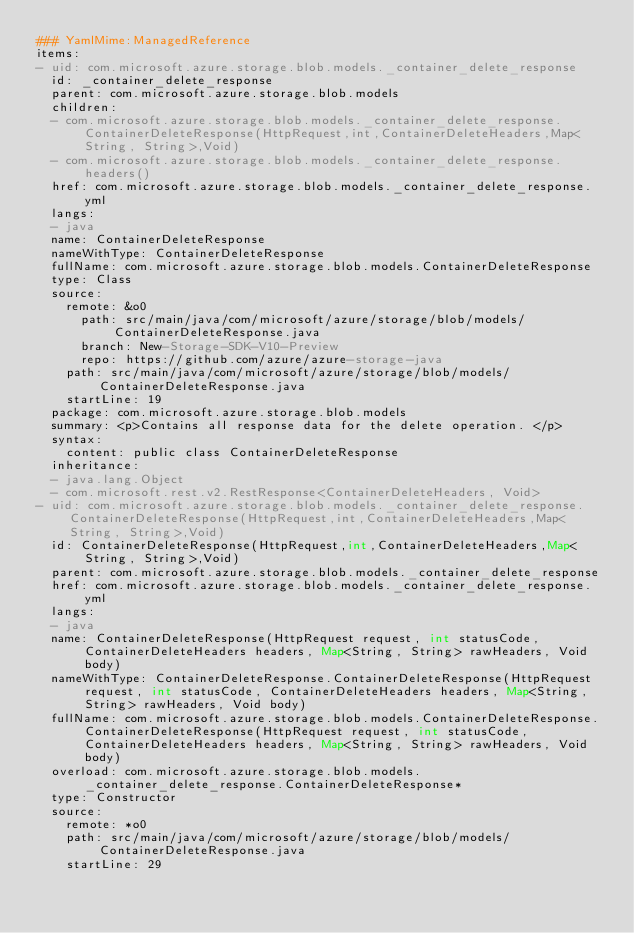Convert code to text. <code><loc_0><loc_0><loc_500><loc_500><_YAML_>### YamlMime:ManagedReference
items:
- uid: com.microsoft.azure.storage.blob.models._container_delete_response
  id: _container_delete_response
  parent: com.microsoft.azure.storage.blob.models
  children:
  - com.microsoft.azure.storage.blob.models._container_delete_response.ContainerDeleteResponse(HttpRequest,int,ContainerDeleteHeaders,Map<String, String>,Void)
  - com.microsoft.azure.storage.blob.models._container_delete_response.headers()
  href: com.microsoft.azure.storage.blob.models._container_delete_response.yml
  langs:
  - java
  name: ContainerDeleteResponse
  nameWithType: ContainerDeleteResponse
  fullName: com.microsoft.azure.storage.blob.models.ContainerDeleteResponse
  type: Class
  source:
    remote: &o0
      path: src/main/java/com/microsoft/azure/storage/blob/models/ContainerDeleteResponse.java
      branch: New-Storage-SDK-V10-Preview
      repo: https://github.com/azure/azure-storage-java
    path: src/main/java/com/microsoft/azure/storage/blob/models/ContainerDeleteResponse.java
    startLine: 19
  package: com.microsoft.azure.storage.blob.models
  summary: <p>Contains all response data for the delete operation. </p>
  syntax:
    content: public class ContainerDeleteResponse
  inheritance:
  - java.lang.Object
  - com.microsoft.rest.v2.RestResponse<ContainerDeleteHeaders, Void>
- uid: com.microsoft.azure.storage.blob.models._container_delete_response.ContainerDeleteResponse(HttpRequest,int,ContainerDeleteHeaders,Map<String, String>,Void)
  id: ContainerDeleteResponse(HttpRequest,int,ContainerDeleteHeaders,Map<String, String>,Void)
  parent: com.microsoft.azure.storage.blob.models._container_delete_response
  href: com.microsoft.azure.storage.blob.models._container_delete_response.yml
  langs:
  - java
  name: ContainerDeleteResponse(HttpRequest request, int statusCode, ContainerDeleteHeaders headers, Map<String, String> rawHeaders, Void body)
  nameWithType: ContainerDeleteResponse.ContainerDeleteResponse(HttpRequest request, int statusCode, ContainerDeleteHeaders headers, Map<String, String> rawHeaders, Void body)
  fullName: com.microsoft.azure.storage.blob.models.ContainerDeleteResponse.ContainerDeleteResponse(HttpRequest request, int statusCode, ContainerDeleteHeaders headers, Map<String, String> rawHeaders, Void body)
  overload: com.microsoft.azure.storage.blob.models._container_delete_response.ContainerDeleteResponse*
  type: Constructor
  source:
    remote: *o0
    path: src/main/java/com/microsoft/azure/storage/blob/models/ContainerDeleteResponse.java
    startLine: 29</code> 